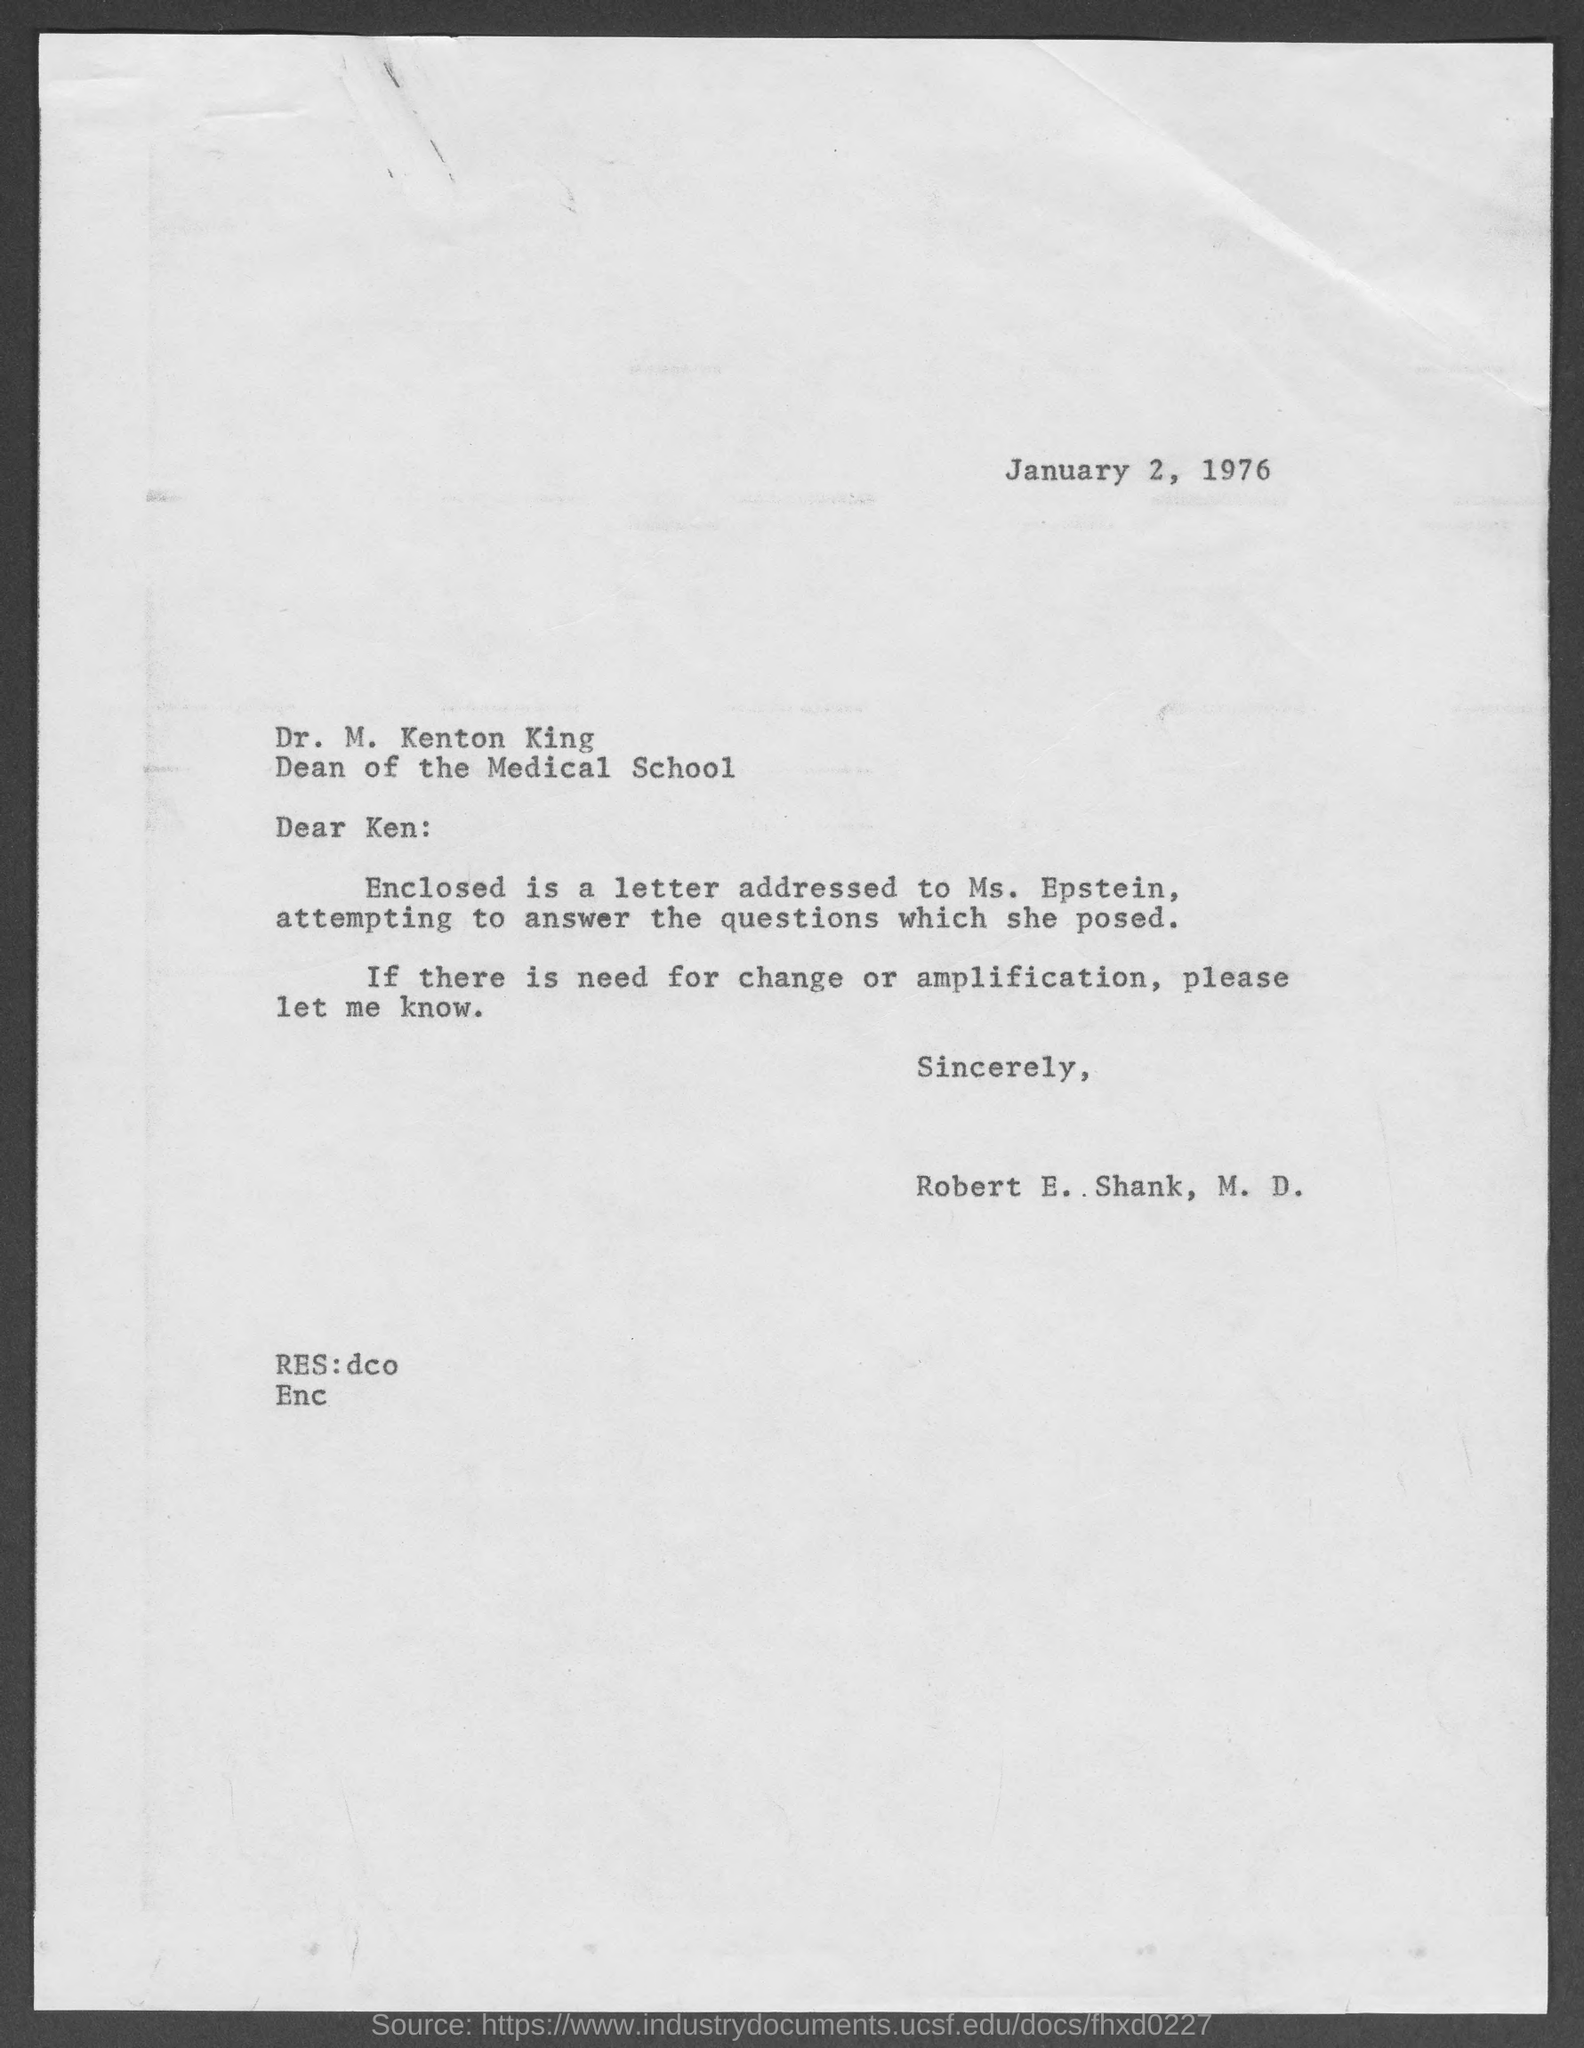Mention a couple of crucial points in this snapshot. The enclosed letter is addressed to Ms. Epstein. Ken has been designated as the Dean of the Medical School. The document is dated January 2, 1976. The sender is Robert E. Shank. The letter is addressed to Dr. M. Kenton King. 